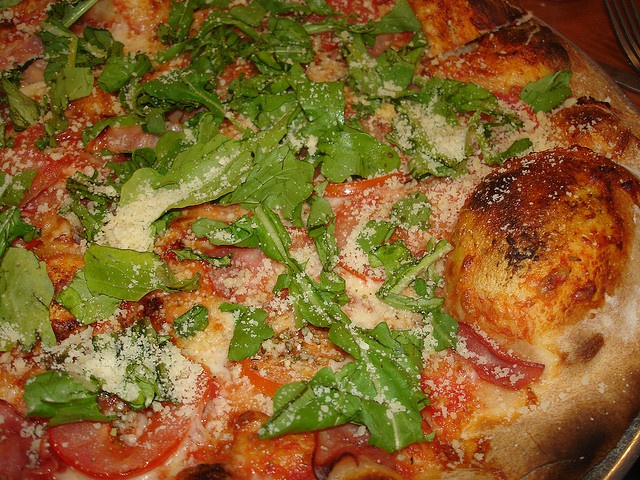Describe the objects in this image and their specific colors. I can see pizza in darkgreen, olive, brown, tan, and maroon tones, fork in darkgreen, black, maroon, and brown tones, and knife in darkgreen, black, maroon, and gray tones in this image. 